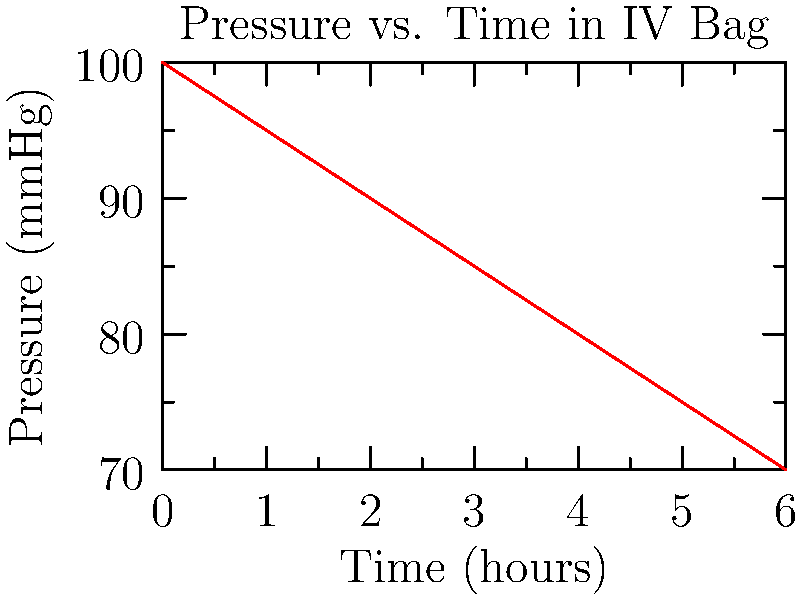An IV bag is hung at a height that initially produces a pressure of 100 mmHg. As the fluid level decreases over time, the pressure in the bag changes as shown in the graph. What is the rate of pressure decrease in mmHg per hour? To find the rate of pressure decrease, we need to follow these steps:

1. Identify the initial and final pressure values:
   Initial pressure (at t = 0): 100 mmHg
   Final pressure (at t = 6 hours): 70 mmHg

2. Calculate the total pressure change:
   $\Delta P = P_{final} - P_{initial} = 70 - 100 = -30$ mmHg

3. Calculate the time interval:
   $\Delta t = t_{final} - t_{initial} = 6 - 0 = 6$ hours

4. Calculate the rate of pressure change:
   Rate = $\frac{\Delta P}{\Delta t} = \frac{-30 \text{ mmHg}}{6 \text{ hours}} = -5 \text{ mmHg/hour}$

The negative sign indicates that the pressure is decreasing over time.
Answer: -5 mmHg/hour 